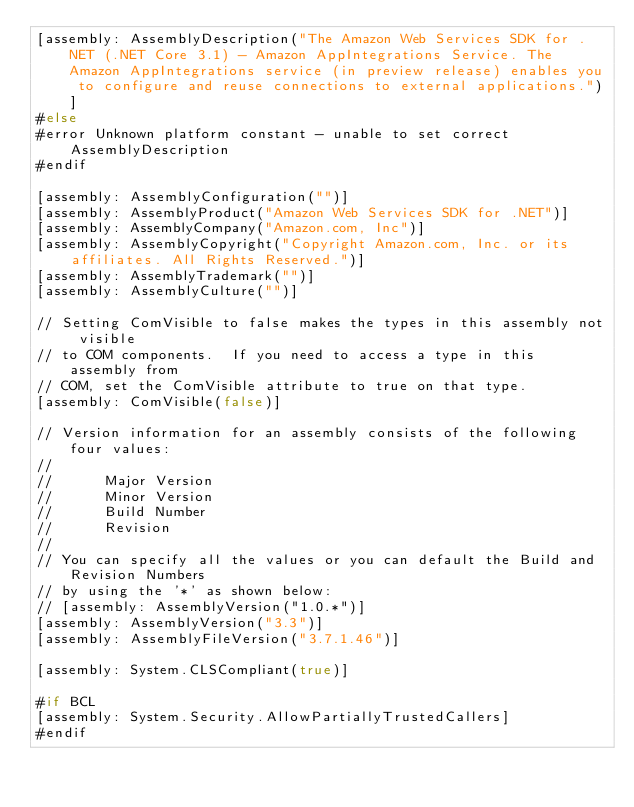<code> <loc_0><loc_0><loc_500><loc_500><_C#_>[assembly: AssemblyDescription("The Amazon Web Services SDK for .NET (.NET Core 3.1) - Amazon AppIntegrations Service. The Amazon AppIntegrations service (in preview release) enables you to configure and reuse connections to external applications.")]
#else
#error Unknown platform constant - unable to set correct AssemblyDescription
#endif

[assembly: AssemblyConfiguration("")]
[assembly: AssemblyProduct("Amazon Web Services SDK for .NET")]
[assembly: AssemblyCompany("Amazon.com, Inc")]
[assembly: AssemblyCopyright("Copyright Amazon.com, Inc. or its affiliates. All Rights Reserved.")]
[assembly: AssemblyTrademark("")]
[assembly: AssemblyCulture("")]

// Setting ComVisible to false makes the types in this assembly not visible 
// to COM components.  If you need to access a type in this assembly from 
// COM, set the ComVisible attribute to true on that type.
[assembly: ComVisible(false)]

// Version information for an assembly consists of the following four values:
//
//      Major Version
//      Minor Version 
//      Build Number
//      Revision
//
// You can specify all the values or you can default the Build and Revision Numbers 
// by using the '*' as shown below:
// [assembly: AssemblyVersion("1.0.*")]
[assembly: AssemblyVersion("3.3")]
[assembly: AssemblyFileVersion("3.7.1.46")]

[assembly: System.CLSCompliant(true)]

#if BCL
[assembly: System.Security.AllowPartiallyTrustedCallers]
#endif</code> 